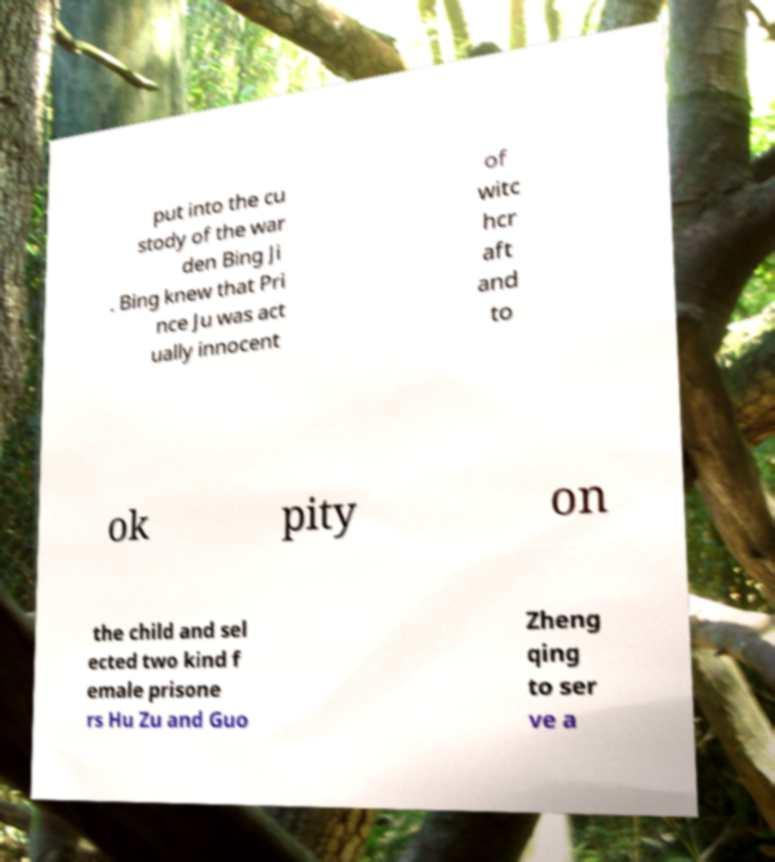Please identify and transcribe the text found in this image. put into the cu stody of the war den Bing Ji . Bing knew that Pri nce Ju was act ually innocent of witc hcr aft and to ok pity on the child and sel ected two kind f emale prisone rs Hu Zu and Guo Zheng qing to ser ve a 